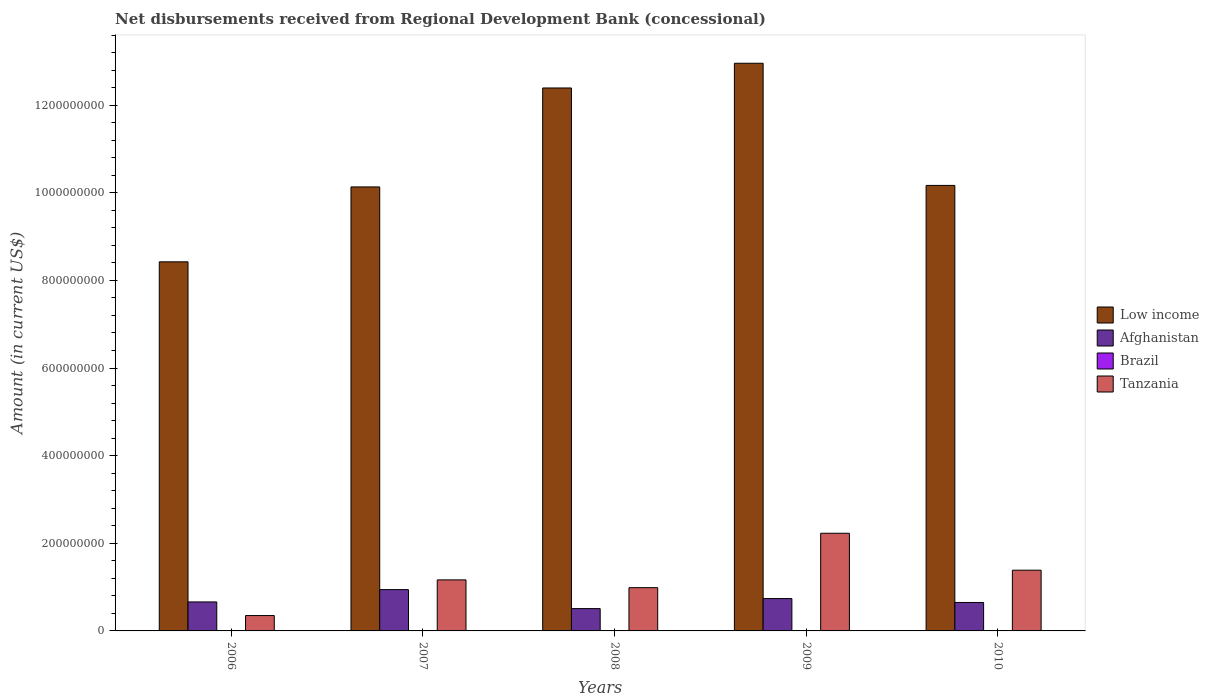How many groups of bars are there?
Provide a short and direct response. 5. Are the number of bars on each tick of the X-axis equal?
Your answer should be compact. Yes. What is the amount of disbursements received from Regional Development Bank in Low income in 2009?
Offer a terse response. 1.30e+09. Across all years, what is the maximum amount of disbursements received from Regional Development Bank in Low income?
Keep it short and to the point. 1.30e+09. Across all years, what is the minimum amount of disbursements received from Regional Development Bank in Afghanistan?
Ensure brevity in your answer.  5.09e+07. In which year was the amount of disbursements received from Regional Development Bank in Afghanistan maximum?
Give a very brief answer. 2007. What is the total amount of disbursements received from Regional Development Bank in Low income in the graph?
Your response must be concise. 5.41e+09. What is the difference between the amount of disbursements received from Regional Development Bank in Afghanistan in 2008 and that in 2010?
Offer a terse response. -1.40e+07. What is the difference between the amount of disbursements received from Regional Development Bank in Low income in 2008 and the amount of disbursements received from Regional Development Bank in Brazil in 2010?
Your answer should be compact. 1.24e+09. What is the average amount of disbursements received from Regional Development Bank in Brazil per year?
Keep it short and to the point. 0. In the year 2008, what is the difference between the amount of disbursements received from Regional Development Bank in Afghanistan and amount of disbursements received from Regional Development Bank in Low income?
Ensure brevity in your answer.  -1.19e+09. In how many years, is the amount of disbursements received from Regional Development Bank in Brazil greater than 1320000000 US$?
Your answer should be compact. 0. What is the ratio of the amount of disbursements received from Regional Development Bank in Tanzania in 2006 to that in 2009?
Provide a succinct answer. 0.16. What is the difference between the highest and the second highest amount of disbursements received from Regional Development Bank in Afghanistan?
Provide a succinct answer. 2.04e+07. What is the difference between the highest and the lowest amount of disbursements received from Regional Development Bank in Low income?
Make the answer very short. 4.53e+08. In how many years, is the amount of disbursements received from Regional Development Bank in Low income greater than the average amount of disbursements received from Regional Development Bank in Low income taken over all years?
Make the answer very short. 2. Is the sum of the amount of disbursements received from Regional Development Bank in Afghanistan in 2006 and 2009 greater than the maximum amount of disbursements received from Regional Development Bank in Low income across all years?
Give a very brief answer. No. Is it the case that in every year, the sum of the amount of disbursements received from Regional Development Bank in Afghanistan and amount of disbursements received from Regional Development Bank in Tanzania is greater than the sum of amount of disbursements received from Regional Development Bank in Low income and amount of disbursements received from Regional Development Bank in Brazil?
Provide a short and direct response. No. Is it the case that in every year, the sum of the amount of disbursements received from Regional Development Bank in Brazil and amount of disbursements received from Regional Development Bank in Low income is greater than the amount of disbursements received from Regional Development Bank in Tanzania?
Your answer should be very brief. Yes. How many bars are there?
Your answer should be very brief. 15. What is the difference between two consecutive major ticks on the Y-axis?
Offer a very short reply. 2.00e+08. Are the values on the major ticks of Y-axis written in scientific E-notation?
Provide a short and direct response. No. Where does the legend appear in the graph?
Your answer should be very brief. Center right. What is the title of the graph?
Keep it short and to the point. Net disbursements received from Regional Development Bank (concessional). Does "Guyana" appear as one of the legend labels in the graph?
Your answer should be very brief. No. What is the label or title of the X-axis?
Make the answer very short. Years. What is the Amount (in current US$) in Low income in 2006?
Provide a short and direct response. 8.42e+08. What is the Amount (in current US$) of Afghanistan in 2006?
Your response must be concise. 6.62e+07. What is the Amount (in current US$) in Brazil in 2006?
Provide a short and direct response. 0. What is the Amount (in current US$) of Tanzania in 2006?
Give a very brief answer. 3.51e+07. What is the Amount (in current US$) of Low income in 2007?
Provide a succinct answer. 1.01e+09. What is the Amount (in current US$) in Afghanistan in 2007?
Your response must be concise. 9.43e+07. What is the Amount (in current US$) in Tanzania in 2007?
Give a very brief answer. 1.16e+08. What is the Amount (in current US$) of Low income in 2008?
Offer a terse response. 1.24e+09. What is the Amount (in current US$) of Afghanistan in 2008?
Give a very brief answer. 5.09e+07. What is the Amount (in current US$) in Brazil in 2008?
Provide a succinct answer. 0. What is the Amount (in current US$) of Tanzania in 2008?
Your response must be concise. 9.87e+07. What is the Amount (in current US$) of Low income in 2009?
Your response must be concise. 1.30e+09. What is the Amount (in current US$) of Afghanistan in 2009?
Give a very brief answer. 7.39e+07. What is the Amount (in current US$) of Brazil in 2009?
Provide a succinct answer. 0. What is the Amount (in current US$) in Tanzania in 2009?
Your answer should be very brief. 2.23e+08. What is the Amount (in current US$) of Low income in 2010?
Offer a terse response. 1.02e+09. What is the Amount (in current US$) of Afghanistan in 2010?
Your answer should be very brief. 6.49e+07. What is the Amount (in current US$) in Tanzania in 2010?
Give a very brief answer. 1.39e+08. Across all years, what is the maximum Amount (in current US$) of Low income?
Offer a very short reply. 1.30e+09. Across all years, what is the maximum Amount (in current US$) of Afghanistan?
Make the answer very short. 9.43e+07. Across all years, what is the maximum Amount (in current US$) in Tanzania?
Provide a short and direct response. 2.23e+08. Across all years, what is the minimum Amount (in current US$) of Low income?
Make the answer very short. 8.42e+08. Across all years, what is the minimum Amount (in current US$) in Afghanistan?
Make the answer very short. 5.09e+07. Across all years, what is the minimum Amount (in current US$) in Tanzania?
Keep it short and to the point. 3.51e+07. What is the total Amount (in current US$) of Low income in the graph?
Provide a succinct answer. 5.41e+09. What is the total Amount (in current US$) of Afghanistan in the graph?
Make the answer very short. 3.50e+08. What is the total Amount (in current US$) of Brazil in the graph?
Offer a very short reply. 0. What is the total Amount (in current US$) of Tanzania in the graph?
Your response must be concise. 6.12e+08. What is the difference between the Amount (in current US$) of Low income in 2006 and that in 2007?
Your answer should be very brief. -1.71e+08. What is the difference between the Amount (in current US$) of Afghanistan in 2006 and that in 2007?
Your response must be concise. -2.81e+07. What is the difference between the Amount (in current US$) of Tanzania in 2006 and that in 2007?
Offer a very short reply. -8.14e+07. What is the difference between the Amount (in current US$) in Low income in 2006 and that in 2008?
Ensure brevity in your answer.  -3.97e+08. What is the difference between the Amount (in current US$) in Afghanistan in 2006 and that in 2008?
Make the answer very short. 1.52e+07. What is the difference between the Amount (in current US$) in Tanzania in 2006 and that in 2008?
Give a very brief answer. -6.37e+07. What is the difference between the Amount (in current US$) in Low income in 2006 and that in 2009?
Your answer should be compact. -4.53e+08. What is the difference between the Amount (in current US$) in Afghanistan in 2006 and that in 2009?
Give a very brief answer. -7.69e+06. What is the difference between the Amount (in current US$) of Tanzania in 2006 and that in 2009?
Make the answer very short. -1.88e+08. What is the difference between the Amount (in current US$) in Low income in 2006 and that in 2010?
Offer a terse response. -1.74e+08. What is the difference between the Amount (in current US$) in Afghanistan in 2006 and that in 2010?
Provide a short and direct response. 1.24e+06. What is the difference between the Amount (in current US$) in Tanzania in 2006 and that in 2010?
Your response must be concise. -1.04e+08. What is the difference between the Amount (in current US$) in Low income in 2007 and that in 2008?
Your answer should be compact. -2.26e+08. What is the difference between the Amount (in current US$) in Afghanistan in 2007 and that in 2008?
Provide a short and direct response. 4.33e+07. What is the difference between the Amount (in current US$) in Tanzania in 2007 and that in 2008?
Provide a short and direct response. 1.77e+07. What is the difference between the Amount (in current US$) of Low income in 2007 and that in 2009?
Keep it short and to the point. -2.82e+08. What is the difference between the Amount (in current US$) of Afghanistan in 2007 and that in 2009?
Ensure brevity in your answer.  2.04e+07. What is the difference between the Amount (in current US$) of Tanzania in 2007 and that in 2009?
Make the answer very short. -1.06e+08. What is the difference between the Amount (in current US$) in Low income in 2007 and that in 2010?
Make the answer very short. -3.46e+06. What is the difference between the Amount (in current US$) in Afghanistan in 2007 and that in 2010?
Your answer should be very brief. 2.93e+07. What is the difference between the Amount (in current US$) in Tanzania in 2007 and that in 2010?
Offer a very short reply. -2.21e+07. What is the difference between the Amount (in current US$) of Low income in 2008 and that in 2009?
Your answer should be very brief. -5.64e+07. What is the difference between the Amount (in current US$) in Afghanistan in 2008 and that in 2009?
Offer a very short reply. -2.29e+07. What is the difference between the Amount (in current US$) of Tanzania in 2008 and that in 2009?
Your response must be concise. -1.24e+08. What is the difference between the Amount (in current US$) of Low income in 2008 and that in 2010?
Your response must be concise. 2.22e+08. What is the difference between the Amount (in current US$) of Afghanistan in 2008 and that in 2010?
Offer a very short reply. -1.40e+07. What is the difference between the Amount (in current US$) of Tanzania in 2008 and that in 2010?
Your response must be concise. -3.98e+07. What is the difference between the Amount (in current US$) of Low income in 2009 and that in 2010?
Provide a succinct answer. 2.79e+08. What is the difference between the Amount (in current US$) of Afghanistan in 2009 and that in 2010?
Offer a terse response. 8.93e+06. What is the difference between the Amount (in current US$) of Tanzania in 2009 and that in 2010?
Ensure brevity in your answer.  8.43e+07. What is the difference between the Amount (in current US$) in Low income in 2006 and the Amount (in current US$) in Afghanistan in 2007?
Keep it short and to the point. 7.48e+08. What is the difference between the Amount (in current US$) of Low income in 2006 and the Amount (in current US$) of Tanzania in 2007?
Keep it short and to the point. 7.26e+08. What is the difference between the Amount (in current US$) of Afghanistan in 2006 and the Amount (in current US$) of Tanzania in 2007?
Keep it short and to the point. -5.03e+07. What is the difference between the Amount (in current US$) of Low income in 2006 and the Amount (in current US$) of Afghanistan in 2008?
Offer a terse response. 7.91e+08. What is the difference between the Amount (in current US$) in Low income in 2006 and the Amount (in current US$) in Tanzania in 2008?
Provide a succinct answer. 7.44e+08. What is the difference between the Amount (in current US$) of Afghanistan in 2006 and the Amount (in current US$) of Tanzania in 2008?
Offer a very short reply. -3.26e+07. What is the difference between the Amount (in current US$) in Low income in 2006 and the Amount (in current US$) in Afghanistan in 2009?
Provide a short and direct response. 7.69e+08. What is the difference between the Amount (in current US$) of Low income in 2006 and the Amount (in current US$) of Tanzania in 2009?
Provide a succinct answer. 6.20e+08. What is the difference between the Amount (in current US$) of Afghanistan in 2006 and the Amount (in current US$) of Tanzania in 2009?
Your response must be concise. -1.57e+08. What is the difference between the Amount (in current US$) of Low income in 2006 and the Amount (in current US$) of Afghanistan in 2010?
Offer a terse response. 7.77e+08. What is the difference between the Amount (in current US$) in Low income in 2006 and the Amount (in current US$) in Tanzania in 2010?
Keep it short and to the point. 7.04e+08. What is the difference between the Amount (in current US$) in Afghanistan in 2006 and the Amount (in current US$) in Tanzania in 2010?
Your response must be concise. -7.24e+07. What is the difference between the Amount (in current US$) of Low income in 2007 and the Amount (in current US$) of Afghanistan in 2008?
Provide a succinct answer. 9.62e+08. What is the difference between the Amount (in current US$) in Low income in 2007 and the Amount (in current US$) in Tanzania in 2008?
Your answer should be very brief. 9.15e+08. What is the difference between the Amount (in current US$) of Afghanistan in 2007 and the Amount (in current US$) of Tanzania in 2008?
Ensure brevity in your answer.  -4.47e+06. What is the difference between the Amount (in current US$) in Low income in 2007 and the Amount (in current US$) in Afghanistan in 2009?
Offer a terse response. 9.39e+08. What is the difference between the Amount (in current US$) of Low income in 2007 and the Amount (in current US$) of Tanzania in 2009?
Your answer should be very brief. 7.90e+08. What is the difference between the Amount (in current US$) in Afghanistan in 2007 and the Amount (in current US$) in Tanzania in 2009?
Offer a terse response. -1.29e+08. What is the difference between the Amount (in current US$) of Low income in 2007 and the Amount (in current US$) of Afghanistan in 2010?
Your answer should be very brief. 9.48e+08. What is the difference between the Amount (in current US$) in Low income in 2007 and the Amount (in current US$) in Tanzania in 2010?
Your response must be concise. 8.75e+08. What is the difference between the Amount (in current US$) of Afghanistan in 2007 and the Amount (in current US$) of Tanzania in 2010?
Make the answer very short. -4.43e+07. What is the difference between the Amount (in current US$) in Low income in 2008 and the Amount (in current US$) in Afghanistan in 2009?
Keep it short and to the point. 1.17e+09. What is the difference between the Amount (in current US$) in Low income in 2008 and the Amount (in current US$) in Tanzania in 2009?
Offer a terse response. 1.02e+09. What is the difference between the Amount (in current US$) of Afghanistan in 2008 and the Amount (in current US$) of Tanzania in 2009?
Your answer should be very brief. -1.72e+08. What is the difference between the Amount (in current US$) in Low income in 2008 and the Amount (in current US$) in Afghanistan in 2010?
Your answer should be very brief. 1.17e+09. What is the difference between the Amount (in current US$) in Low income in 2008 and the Amount (in current US$) in Tanzania in 2010?
Offer a very short reply. 1.10e+09. What is the difference between the Amount (in current US$) of Afghanistan in 2008 and the Amount (in current US$) of Tanzania in 2010?
Keep it short and to the point. -8.76e+07. What is the difference between the Amount (in current US$) in Low income in 2009 and the Amount (in current US$) in Afghanistan in 2010?
Make the answer very short. 1.23e+09. What is the difference between the Amount (in current US$) in Low income in 2009 and the Amount (in current US$) in Tanzania in 2010?
Offer a terse response. 1.16e+09. What is the difference between the Amount (in current US$) of Afghanistan in 2009 and the Amount (in current US$) of Tanzania in 2010?
Your response must be concise. -6.47e+07. What is the average Amount (in current US$) in Low income per year?
Give a very brief answer. 1.08e+09. What is the average Amount (in current US$) in Afghanistan per year?
Offer a terse response. 7.00e+07. What is the average Amount (in current US$) in Brazil per year?
Your answer should be very brief. 0. What is the average Amount (in current US$) of Tanzania per year?
Your answer should be very brief. 1.22e+08. In the year 2006, what is the difference between the Amount (in current US$) in Low income and Amount (in current US$) in Afghanistan?
Your answer should be very brief. 7.76e+08. In the year 2006, what is the difference between the Amount (in current US$) of Low income and Amount (in current US$) of Tanzania?
Offer a terse response. 8.07e+08. In the year 2006, what is the difference between the Amount (in current US$) of Afghanistan and Amount (in current US$) of Tanzania?
Keep it short and to the point. 3.11e+07. In the year 2007, what is the difference between the Amount (in current US$) of Low income and Amount (in current US$) of Afghanistan?
Your response must be concise. 9.19e+08. In the year 2007, what is the difference between the Amount (in current US$) in Low income and Amount (in current US$) in Tanzania?
Your response must be concise. 8.97e+08. In the year 2007, what is the difference between the Amount (in current US$) of Afghanistan and Amount (in current US$) of Tanzania?
Give a very brief answer. -2.22e+07. In the year 2008, what is the difference between the Amount (in current US$) in Low income and Amount (in current US$) in Afghanistan?
Keep it short and to the point. 1.19e+09. In the year 2008, what is the difference between the Amount (in current US$) of Low income and Amount (in current US$) of Tanzania?
Provide a succinct answer. 1.14e+09. In the year 2008, what is the difference between the Amount (in current US$) of Afghanistan and Amount (in current US$) of Tanzania?
Give a very brief answer. -4.78e+07. In the year 2009, what is the difference between the Amount (in current US$) in Low income and Amount (in current US$) in Afghanistan?
Offer a very short reply. 1.22e+09. In the year 2009, what is the difference between the Amount (in current US$) in Low income and Amount (in current US$) in Tanzania?
Make the answer very short. 1.07e+09. In the year 2009, what is the difference between the Amount (in current US$) in Afghanistan and Amount (in current US$) in Tanzania?
Provide a succinct answer. -1.49e+08. In the year 2010, what is the difference between the Amount (in current US$) in Low income and Amount (in current US$) in Afghanistan?
Provide a succinct answer. 9.52e+08. In the year 2010, what is the difference between the Amount (in current US$) in Low income and Amount (in current US$) in Tanzania?
Your answer should be compact. 8.78e+08. In the year 2010, what is the difference between the Amount (in current US$) of Afghanistan and Amount (in current US$) of Tanzania?
Offer a terse response. -7.36e+07. What is the ratio of the Amount (in current US$) in Low income in 2006 to that in 2007?
Keep it short and to the point. 0.83. What is the ratio of the Amount (in current US$) in Afghanistan in 2006 to that in 2007?
Ensure brevity in your answer.  0.7. What is the ratio of the Amount (in current US$) of Tanzania in 2006 to that in 2007?
Provide a succinct answer. 0.3. What is the ratio of the Amount (in current US$) in Low income in 2006 to that in 2008?
Offer a very short reply. 0.68. What is the ratio of the Amount (in current US$) of Afghanistan in 2006 to that in 2008?
Give a very brief answer. 1.3. What is the ratio of the Amount (in current US$) in Tanzania in 2006 to that in 2008?
Offer a terse response. 0.35. What is the ratio of the Amount (in current US$) of Low income in 2006 to that in 2009?
Offer a very short reply. 0.65. What is the ratio of the Amount (in current US$) in Afghanistan in 2006 to that in 2009?
Your response must be concise. 0.9. What is the ratio of the Amount (in current US$) of Tanzania in 2006 to that in 2009?
Ensure brevity in your answer.  0.16. What is the ratio of the Amount (in current US$) in Low income in 2006 to that in 2010?
Offer a terse response. 0.83. What is the ratio of the Amount (in current US$) in Afghanistan in 2006 to that in 2010?
Your answer should be very brief. 1.02. What is the ratio of the Amount (in current US$) of Tanzania in 2006 to that in 2010?
Provide a short and direct response. 0.25. What is the ratio of the Amount (in current US$) of Low income in 2007 to that in 2008?
Your answer should be very brief. 0.82. What is the ratio of the Amount (in current US$) in Afghanistan in 2007 to that in 2008?
Your answer should be very brief. 1.85. What is the ratio of the Amount (in current US$) in Tanzania in 2007 to that in 2008?
Provide a short and direct response. 1.18. What is the ratio of the Amount (in current US$) of Low income in 2007 to that in 2009?
Provide a short and direct response. 0.78. What is the ratio of the Amount (in current US$) of Afghanistan in 2007 to that in 2009?
Offer a very short reply. 1.28. What is the ratio of the Amount (in current US$) of Tanzania in 2007 to that in 2009?
Give a very brief answer. 0.52. What is the ratio of the Amount (in current US$) in Low income in 2007 to that in 2010?
Make the answer very short. 1. What is the ratio of the Amount (in current US$) of Afghanistan in 2007 to that in 2010?
Your answer should be compact. 1.45. What is the ratio of the Amount (in current US$) in Tanzania in 2007 to that in 2010?
Provide a succinct answer. 0.84. What is the ratio of the Amount (in current US$) in Low income in 2008 to that in 2009?
Give a very brief answer. 0.96. What is the ratio of the Amount (in current US$) in Afghanistan in 2008 to that in 2009?
Offer a very short reply. 0.69. What is the ratio of the Amount (in current US$) in Tanzania in 2008 to that in 2009?
Your answer should be compact. 0.44. What is the ratio of the Amount (in current US$) of Low income in 2008 to that in 2010?
Make the answer very short. 1.22. What is the ratio of the Amount (in current US$) of Afghanistan in 2008 to that in 2010?
Keep it short and to the point. 0.78. What is the ratio of the Amount (in current US$) of Tanzania in 2008 to that in 2010?
Make the answer very short. 0.71. What is the ratio of the Amount (in current US$) in Low income in 2009 to that in 2010?
Keep it short and to the point. 1.27. What is the ratio of the Amount (in current US$) in Afghanistan in 2009 to that in 2010?
Ensure brevity in your answer.  1.14. What is the ratio of the Amount (in current US$) in Tanzania in 2009 to that in 2010?
Give a very brief answer. 1.61. What is the difference between the highest and the second highest Amount (in current US$) in Low income?
Provide a short and direct response. 5.64e+07. What is the difference between the highest and the second highest Amount (in current US$) in Afghanistan?
Provide a succinct answer. 2.04e+07. What is the difference between the highest and the second highest Amount (in current US$) in Tanzania?
Offer a terse response. 8.43e+07. What is the difference between the highest and the lowest Amount (in current US$) of Low income?
Offer a terse response. 4.53e+08. What is the difference between the highest and the lowest Amount (in current US$) of Afghanistan?
Provide a succinct answer. 4.33e+07. What is the difference between the highest and the lowest Amount (in current US$) in Tanzania?
Your answer should be very brief. 1.88e+08. 